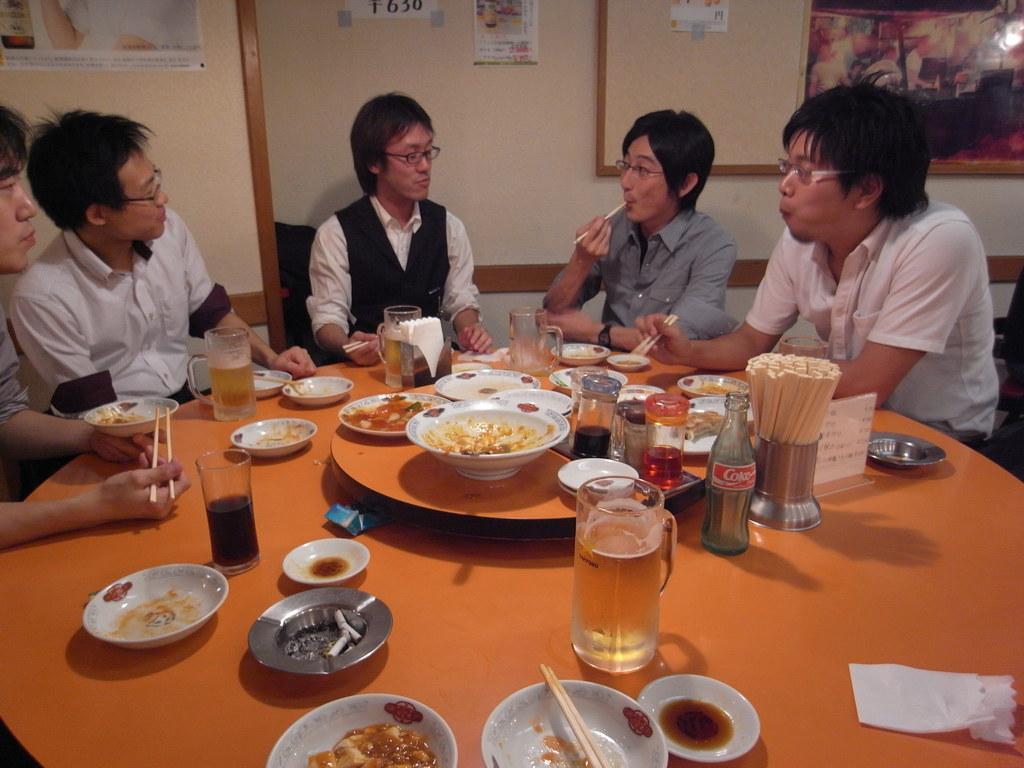In one or two sentences, can you explain what this image depicts? In this image i can see group of people sitting there are few glasses, bowl and the dish in the bowl on the table at the back ground i can see a paper attached to a wall and a board. 